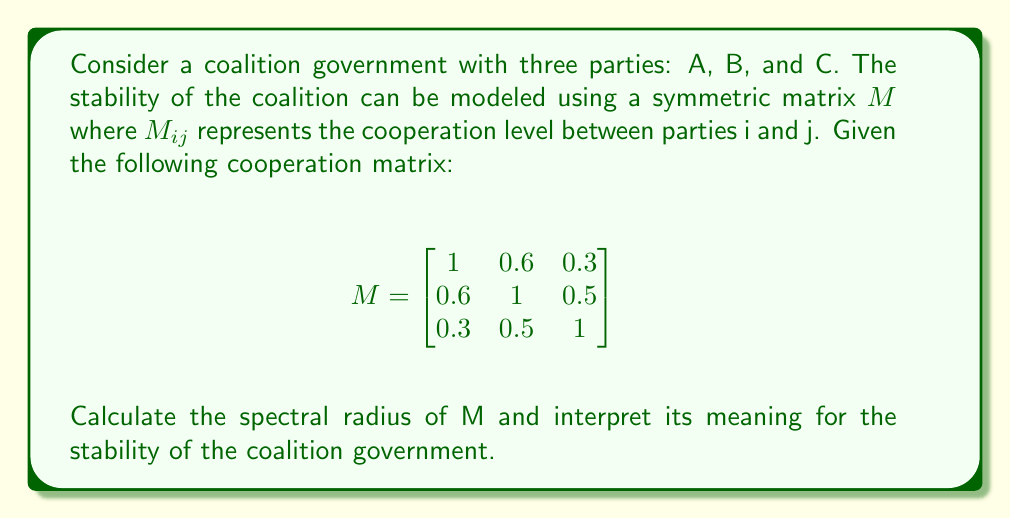Can you solve this math problem? To evaluate the stability of the coalition government using spectral theory, we need to follow these steps:

1) First, we need to find the eigenvalues of the cooperation matrix M. The characteristic equation is:

   $det(M - \lambda I) = 0$

   $\begin{vmatrix}
   1-\lambda & 0.6 & 0.3 \\
   0.6 & 1-\lambda & 0.5 \\
   0.3 & 0.5 & 1-\lambda
   \end{vmatrix} = 0$

2) Expanding this determinant:

   $(1-\lambda)^3 + 2(0.6)(0.5)(0.3) - (1-\lambda)(0.6^2 + 0.5^2 + 0.3^2) = 0$
   
   $-\lambda^3 + 3\lambda^2 - 3\lambda + 1 + 0.18 - (1-\lambda)(0.36 + 0.25 + 0.09) = 0$
   
   $-\lambda^3 + 3\lambda^2 - 3\lambda + 1.18 - 0.7 + 0.7\lambda = 0$
   
   $-\lambda^3 + 3\lambda^2 - 2.3\lambda + 0.48 = 0$

3) Solving this equation (which can be done numerically), we get the eigenvalues:

   $\lambda_1 \approx 1.8428$
   $\lambda_2 \approx 0.8286$
   $\lambda_3 \approx 0.3286$

4) The spectral radius is the largest absolute eigenvalue:

   $\rho(M) = max(|\lambda_i|) = 1.8428$

5) Interpretation: In the context of coalition stability, a larger spectral radius indicates a more stable coalition. The spectral radius is always between 0 and 3 for a 3x3 cooperation matrix with ones on the diagonal.

   - If $\rho(M) = 3$, it indicates perfect cooperation (all entries are 1).
   - If $\rho(M) = 1$, it suggests no cooperation between parties (only diagonal entries are 1).
   - Values between 1 and 3 indicate varying degrees of stability.

   In this case, $\rho(M) = 1.8428$, which is closer to 2 than to 1 or 3. This suggests a moderately stable coalition, with room for improvement in cooperation.
Answer: The spectral radius of the cooperation matrix M is approximately 1.8428, indicating a moderately stable coalition government. 